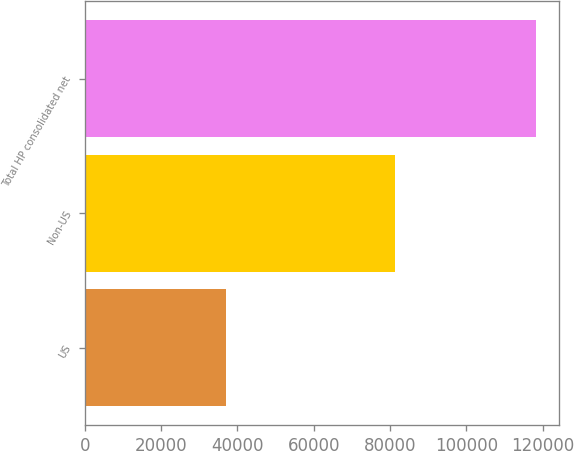<chart> <loc_0><loc_0><loc_500><loc_500><bar_chart><fcel>US<fcel>Non-US<fcel>Total HP consolidated net<nl><fcel>36932<fcel>81432<fcel>118364<nl></chart> 